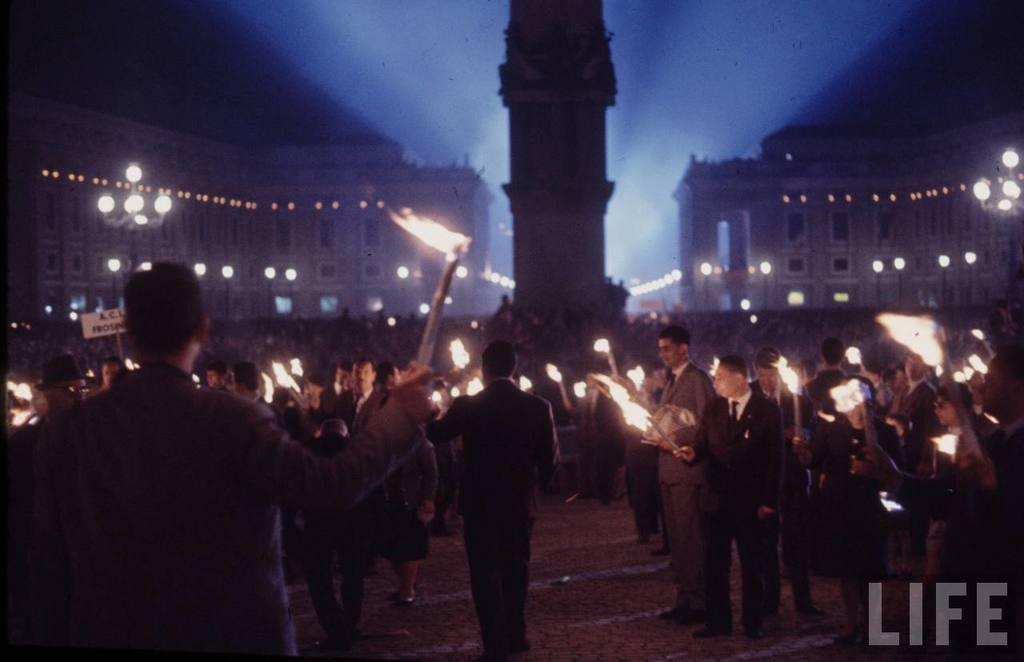What are the people in the image holding? The people in the image are holding fire objects. What type of structures can be seen in the image? There are buildings visible in the image. What can be seen illuminating the scene in the image? Lights are present in the image. What is visible in the background of the image? The sky is visible in the image. How many wounds can be seen on the buildings in the image? There are no wounds visible on the buildings in the image. What type of adjustment is being made to the lights in the image? There is no indication of any adjustment being made to the lights in the image. 